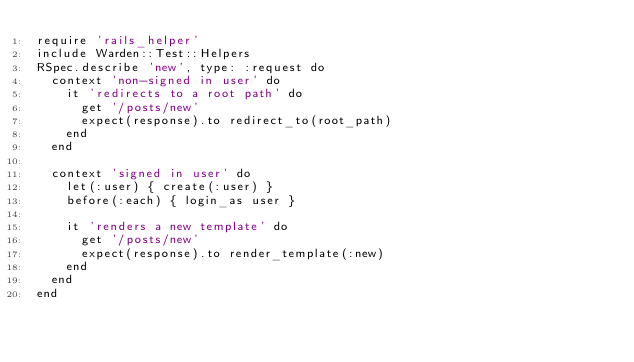<code> <loc_0><loc_0><loc_500><loc_500><_Ruby_>require 'rails_helper'
include Warden::Test::Helpers
RSpec.describe 'new', type: :request do
  context 'non-signed in user' do
    it 'redirects to a root path' do
      get '/posts/new'
      expect(response).to redirect_to(root_path)
    end
  end

  context 'signed in user' do
    let(:user) { create(:user) }
    before(:each) { login_as user }

    it 'renders a new template' do
      get '/posts/new'
      expect(response).to render_template(:new)
    end
  end
end
</code> 